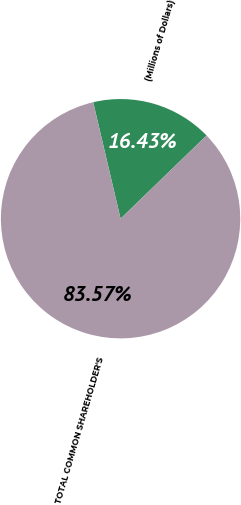<chart> <loc_0><loc_0><loc_500><loc_500><pie_chart><fcel>(Millions of Dollars)<fcel>TOTAL COMMON SHAREHOLDER'S<nl><fcel>16.43%<fcel>83.57%<nl></chart> 